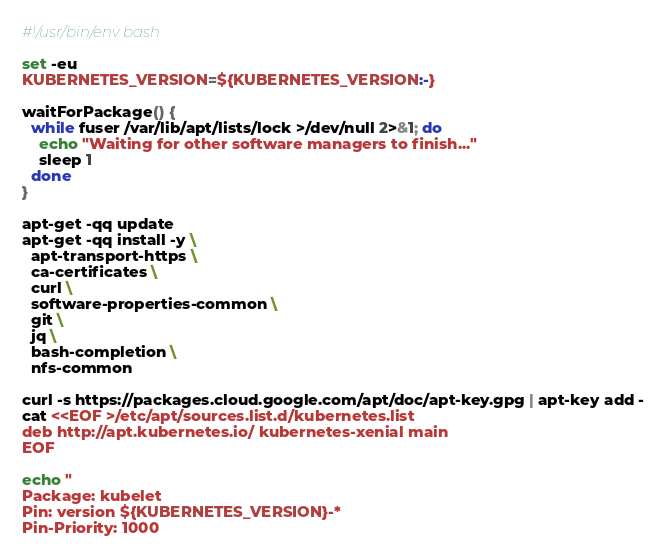<code> <loc_0><loc_0><loc_500><loc_500><_Bash_>#!/usr/bin/env bash

set -eu
KUBERNETES_VERSION=${KUBERNETES_VERSION:-}

waitForPackage() {
  while fuser /var/lib/apt/lists/lock >/dev/null 2>&1; do
    echo "Waiting for other software managers to finish..."
    sleep 1
  done
}

apt-get -qq update
apt-get -qq install -y \
  apt-transport-https \
  ca-certificates \
  curl \
  software-properties-common \
  git \
  jq \
  bash-completion \
  nfs-common

curl -s https://packages.cloud.google.com/apt/doc/apt-key.gpg | apt-key add -
cat <<EOF >/etc/apt/sources.list.d/kubernetes.list
deb http://apt.kubernetes.io/ kubernetes-xenial main
EOF

echo "
Package: kubelet
Pin: version ${KUBERNETES_VERSION}-*
Pin-Priority: 1000</code> 